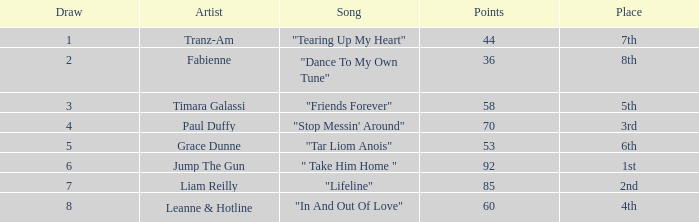What's the typical pull for the song "stop messin' around"? 4.0. 